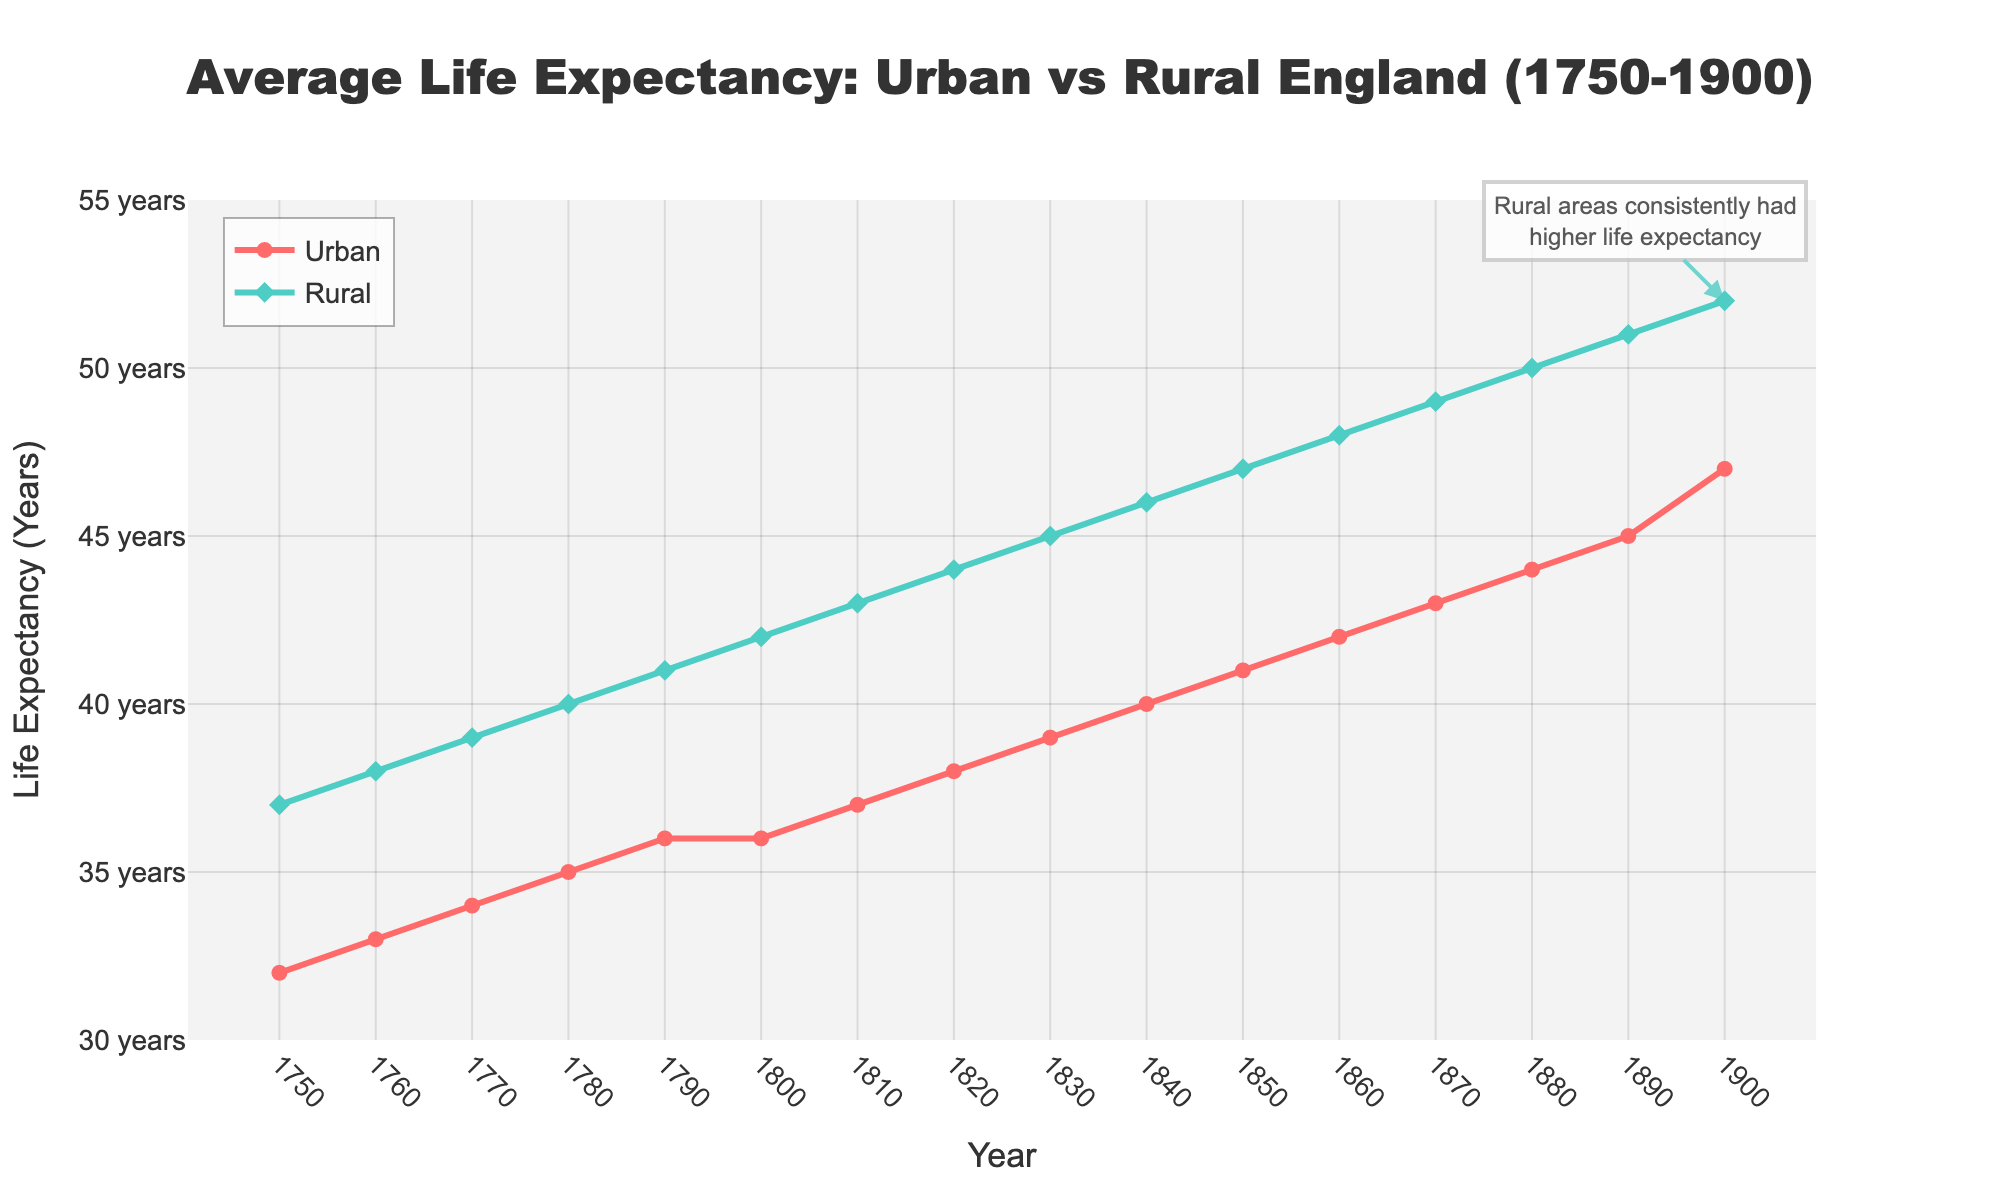What was the urban life expectancy in 1750 and 1900? By looking at the plot, identify the starting and ending points of the urban life expectancy line. The life expectancy in urban areas in 1750 is 32 years and in 1900 it is 47 years.
Answer: 32 years and 47 years What's the difference in life expectancy between rural and urban areas in 1850? Locate the life expectancy values for both urban and rural areas in 1850. Urban life expectancy is 41 years and rural is 47 years. The difference is calculated as 47 - 41.
Answer: 6 years In which year did the rural life expectancy reach 50 years? Find the point where the rural life expectancy line intersects the 50-year mark. This occurs in 1880.
Answer: 1880 Which area (urban or rural) had a higher life expectancy consistently from 1750 to 1900? Compare the two lines throughout the entire period. The green line (rural) is always above the red line (urban), showing higher life expectancy in rural areas throughout the years.
Answer: Rural What is the average life expectancy in urban areas from 1750 to 1900? Add all the urban life expectancy values and divide by the number of years given (16). Sum: 32+33+34+35+36+36+37+38+39+40+41+42+43+44+45+47 = 677. Average is 677 / 16.
Answer: 42.31 years What trend is observed in urban life expectancy from 1750 to 1900? Look at the trajectory of the urban life expectancy line. It shows a continuous increase over this period.
Answer: Continuous increase How do the trends of life expectancy in urban and rural areas compare from 1750 to 1900? Examine both lines over the given period. Both trends show an increase, but the rural life expectancy is consistently higher and increases at a slightly faster rate.
Answer: Both increase, rural higher and faster What was the approximate growth in rural life expectancy from 1750 to 1850? Find the starting and ending values within the specified period. In 1750, rural life expectancy is 37 years, and in 1850, it is 47 years. The growth is 47 - 37.
Answer: 10 years In which decade did the rural life expectancy surpass 45 years? Locate the point on the rural life expectancy line where it first goes above 45. This happens in 1830.
Answer: 1830 What is the visual color used for the urban life expectancy line? Identify the color of the line representing urban life expectancy in the plot. The urban line is in red.
Answer: Red 